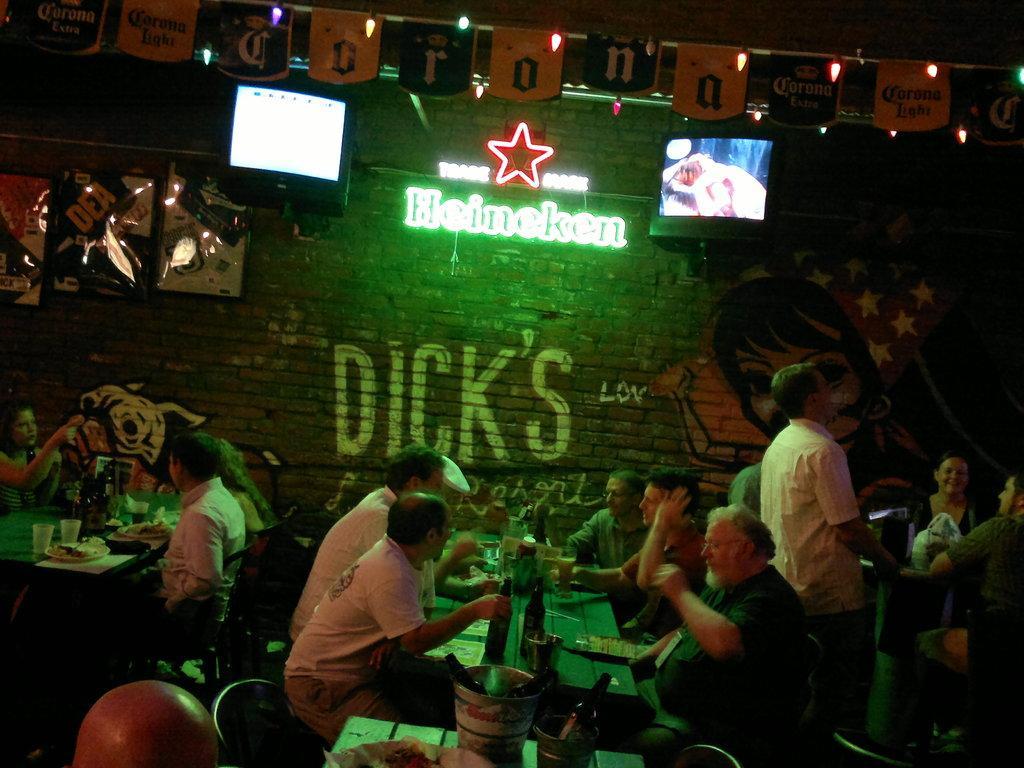Could you give a brief overview of what you see in this image? This picture describes about group of people, few people are seated on the chairs, and a person is standing, in front of them we can see few bottles, bucket and other things on the table, beside to them we can find few monitors, lights and few posters on the wall. 